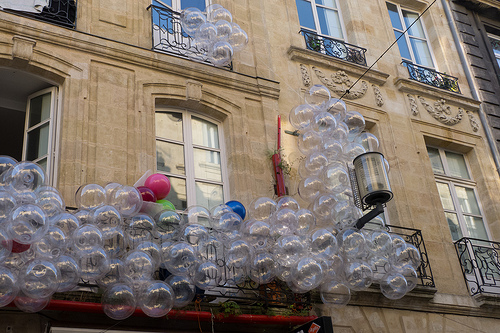<image>
Is the glass balls on the house? Yes. Looking at the image, I can see the glass balls is positioned on top of the house, with the house providing support. Is there a balloons on the building? Yes. Looking at the image, I can see the balloons is positioned on top of the building, with the building providing support. 